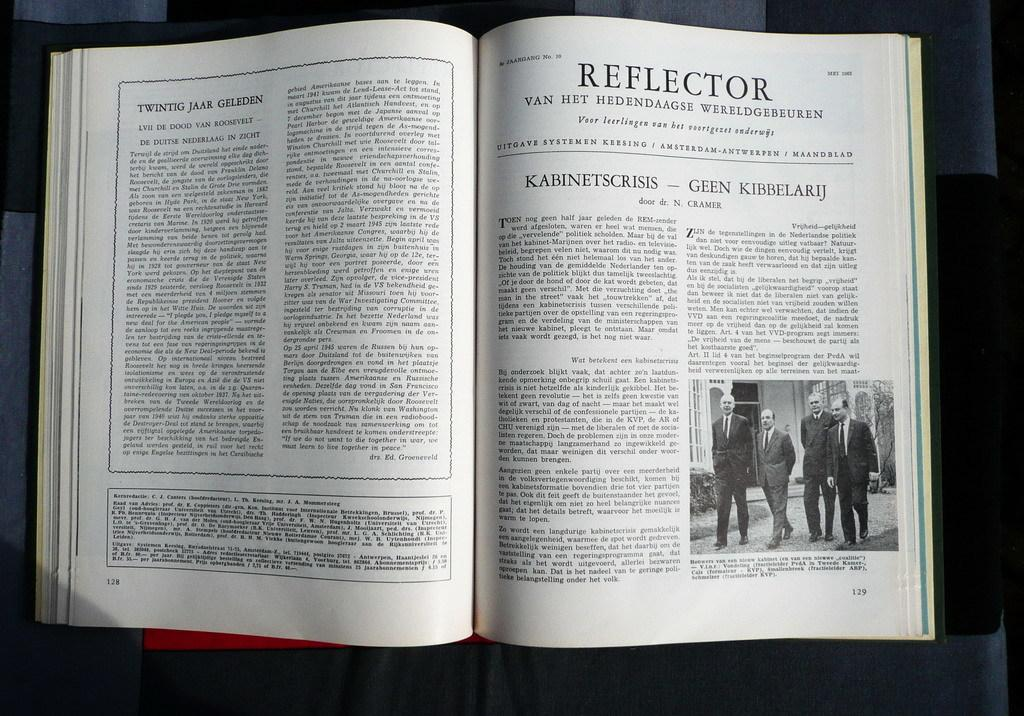<image>
Relay a brief, clear account of the picture shown. A book is open to a page titled Reflector. 